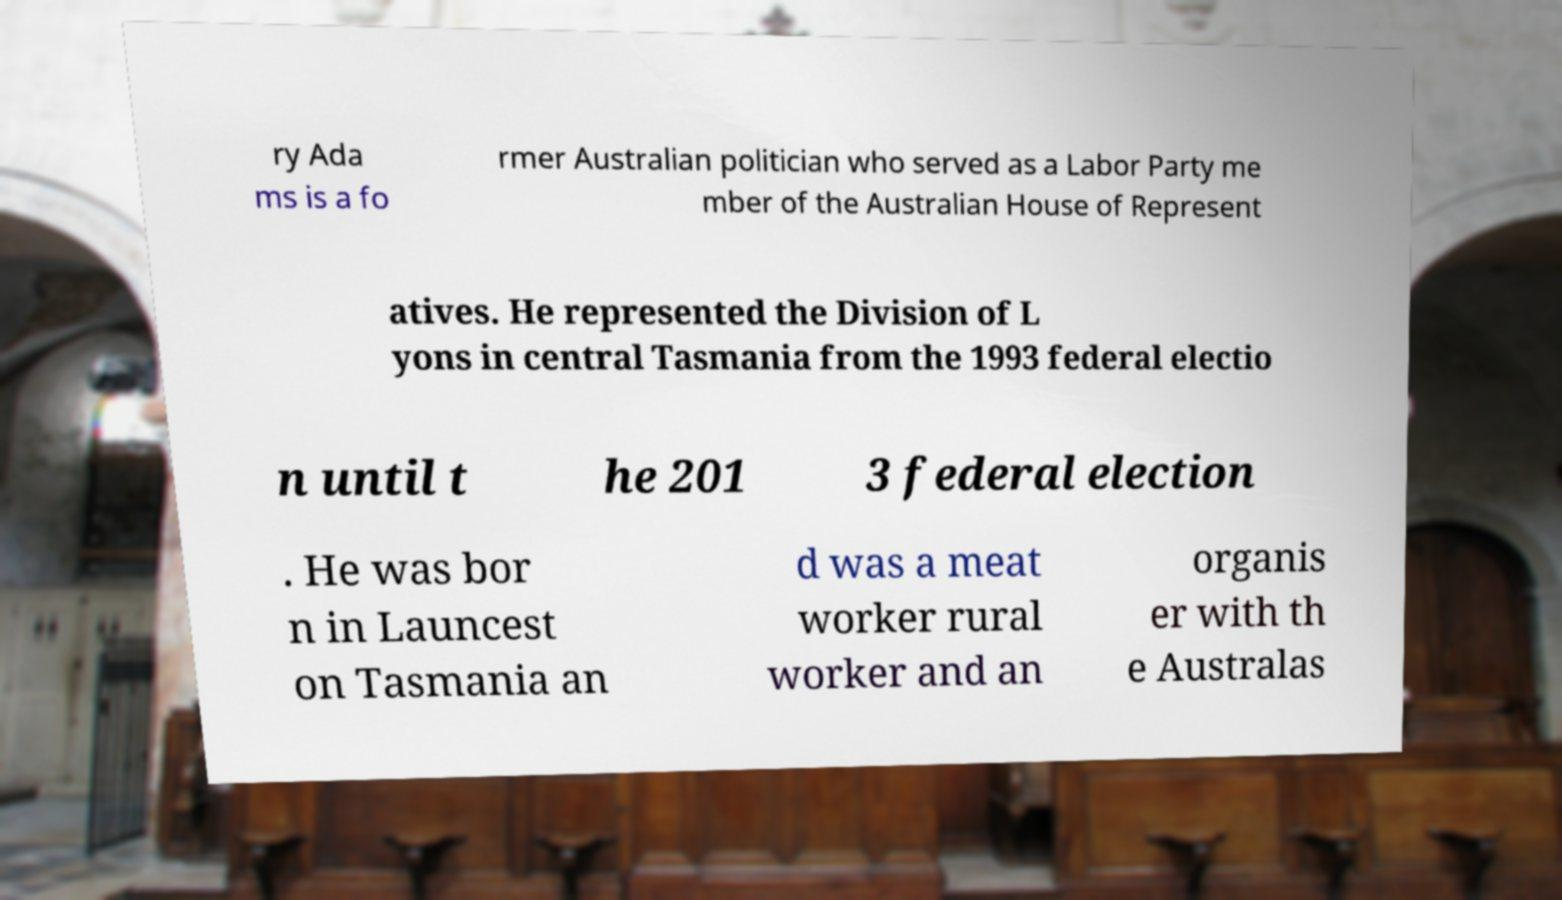For documentation purposes, I need the text within this image transcribed. Could you provide that? ry Ada ms is a fo rmer Australian politician who served as a Labor Party me mber of the Australian House of Represent atives. He represented the Division of L yons in central Tasmania from the 1993 federal electio n until t he 201 3 federal election . He was bor n in Launcest on Tasmania an d was a meat worker rural worker and an organis er with th e Australas 